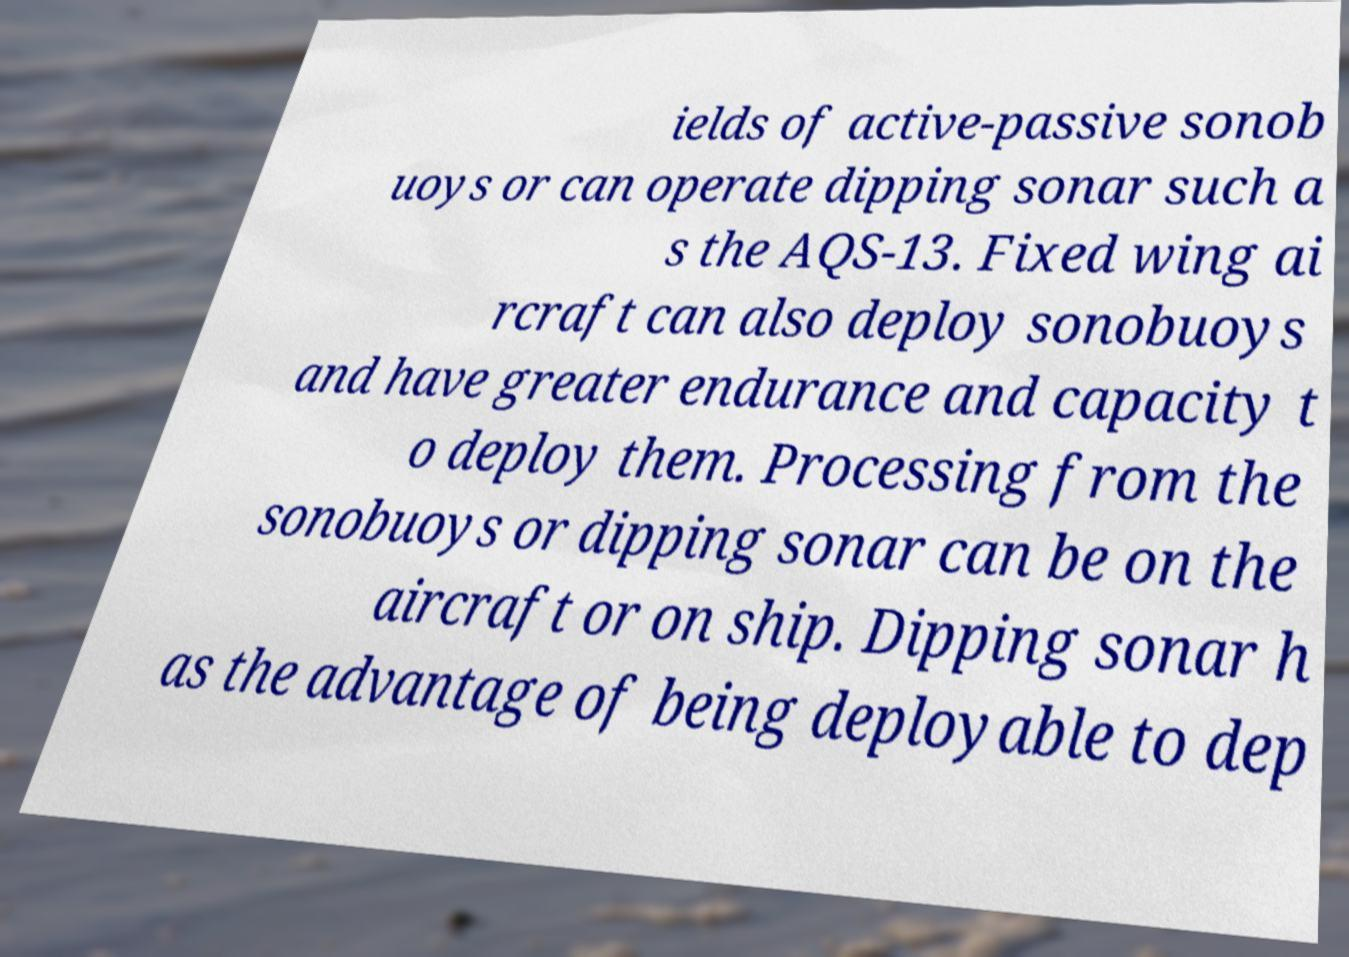Could you assist in decoding the text presented in this image and type it out clearly? ields of active-passive sonob uoys or can operate dipping sonar such a s the AQS-13. Fixed wing ai rcraft can also deploy sonobuoys and have greater endurance and capacity t o deploy them. Processing from the sonobuoys or dipping sonar can be on the aircraft or on ship. Dipping sonar h as the advantage of being deployable to dep 